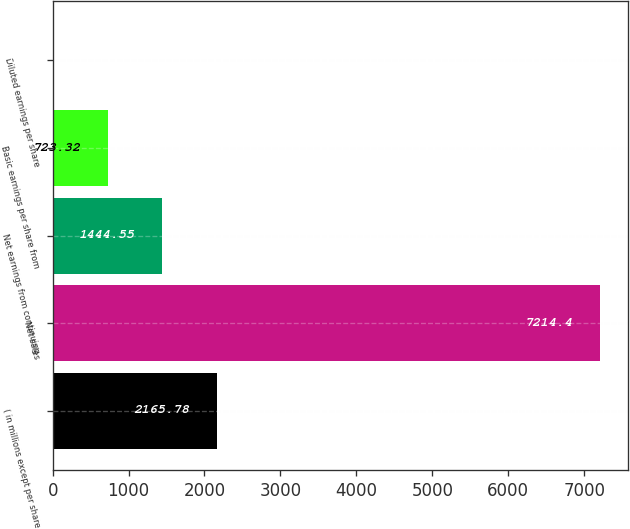<chart> <loc_0><loc_0><loc_500><loc_500><bar_chart><fcel>( in millions except per share<fcel>Net sales<fcel>Net earnings from continuing<fcel>Basic earnings per share from<fcel>Diluted earnings per share<nl><fcel>2165.78<fcel>7214.4<fcel>1444.55<fcel>723.32<fcel>2.09<nl></chart> 